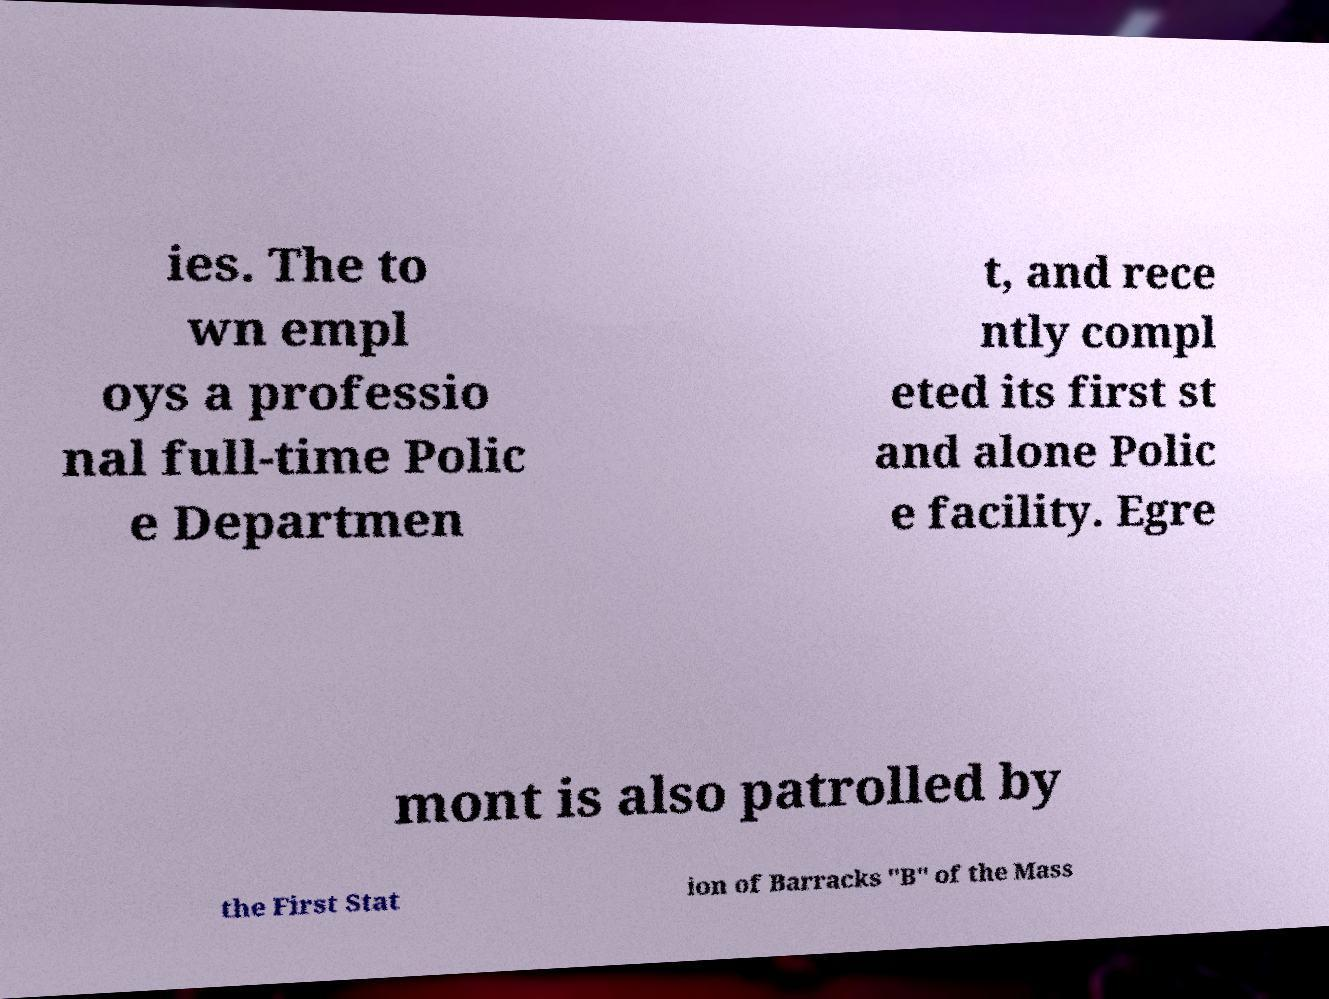There's text embedded in this image that I need extracted. Can you transcribe it verbatim? ies. The to wn empl oys a professio nal full-time Polic e Departmen t, and rece ntly compl eted its first st and alone Polic e facility. Egre mont is also patrolled by the First Stat ion of Barracks "B" of the Mass 